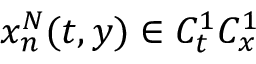<formula> <loc_0><loc_0><loc_500><loc_500>x _ { n } ^ { N } ( t , y ) \in C _ { t } ^ { 1 } C _ { x } ^ { 1 }</formula> 